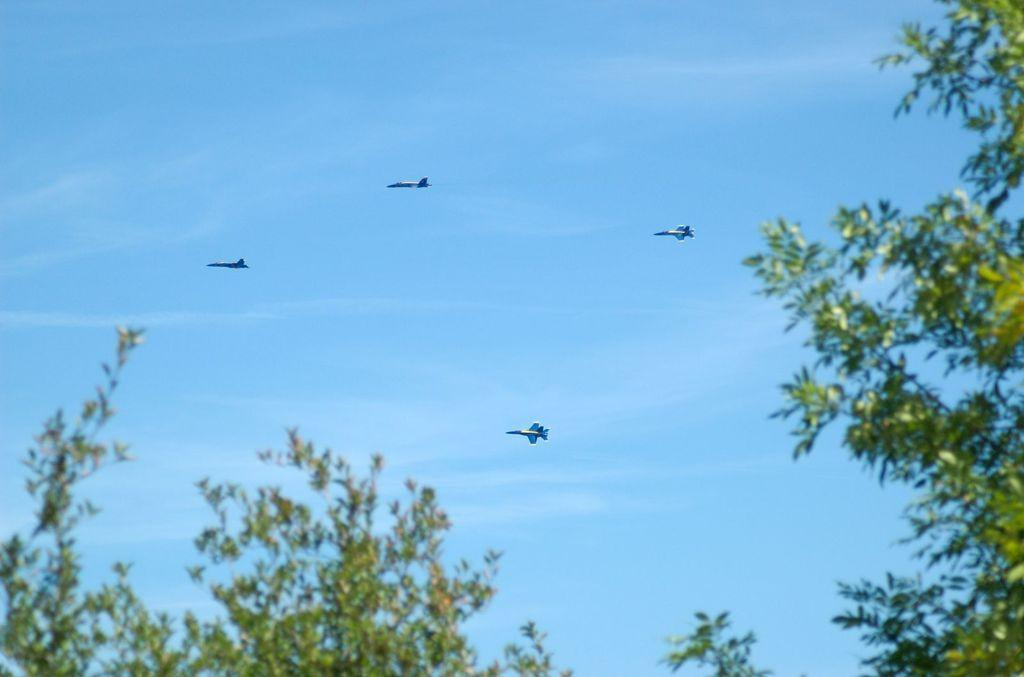What type of vegetation can be seen in the image? There are trees in the image. Can you describe the background of the image? In the background of the image, there are four airplanes flying in the sky. What color is the stocking on the chin of the person in the image? There is no person or stocking present in the image; it features trees and airplanes. 